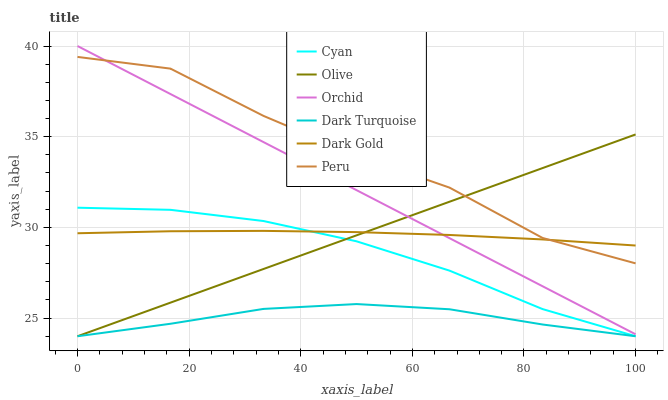Does Peru have the minimum area under the curve?
Answer yes or no. No. Does Dark Turquoise have the maximum area under the curve?
Answer yes or no. No. Is Dark Turquoise the smoothest?
Answer yes or no. No. Is Dark Turquoise the roughest?
Answer yes or no. No. Does Peru have the lowest value?
Answer yes or no. No. Does Peru have the highest value?
Answer yes or no. No. Is Cyan less than Orchid?
Answer yes or no. Yes. Is Peru greater than Dark Turquoise?
Answer yes or no. Yes. Does Cyan intersect Orchid?
Answer yes or no. No. 